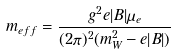Convert formula to latex. <formula><loc_0><loc_0><loc_500><loc_500>m _ { e f f } = \frac { g ^ { 2 } e | B | \mu _ { e } } { ( 2 \pi ) ^ { 2 } ( m _ { W } ^ { 2 } - e | B | ) }</formula> 